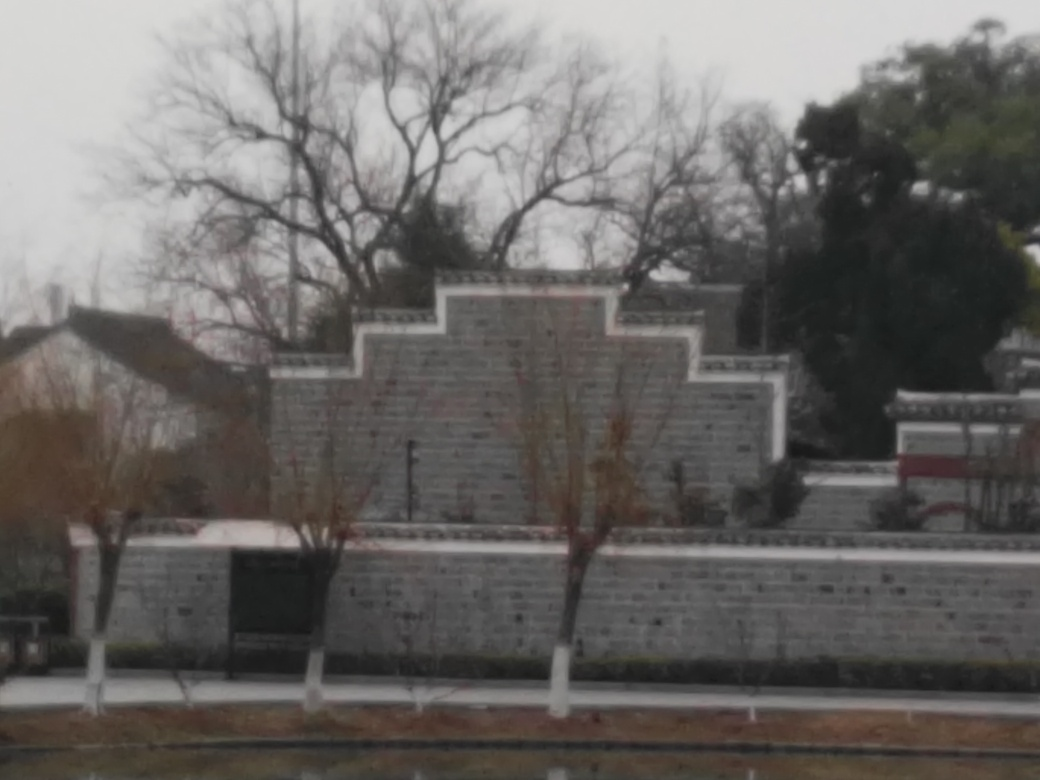Is this place likely to be found in a city or countryside? Given the structured design and the presence of built elements, it is more likely that this place is within an urban area or the outskirts of a city rather than in a rural or countryside setting. 